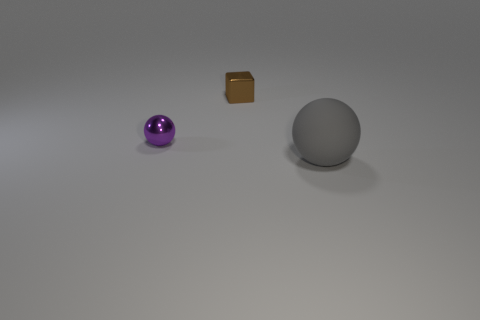Are there any other things that have the same material as the big ball?
Keep it short and to the point. No. Are there any things made of the same material as the gray ball?
Offer a very short reply. No. How many objects are either balls that are behind the big gray ball or spheres that are behind the large sphere?
Provide a succinct answer. 1. What number of other things are there of the same color as the metal ball?
Offer a very short reply. 0. What is the small brown cube made of?
Ensure brevity in your answer.  Metal. There is a ball that is behind the gray matte object; is its size the same as the big rubber sphere?
Offer a terse response. No. Are there any other things that have the same size as the rubber thing?
Your response must be concise. No. What is the size of the other object that is the same shape as the big matte object?
Make the answer very short. Small. Are there the same number of small things right of the brown block and brown cubes that are in front of the purple shiny thing?
Provide a short and direct response. Yes. What is the size of the sphere left of the large thing?
Give a very brief answer. Small. 